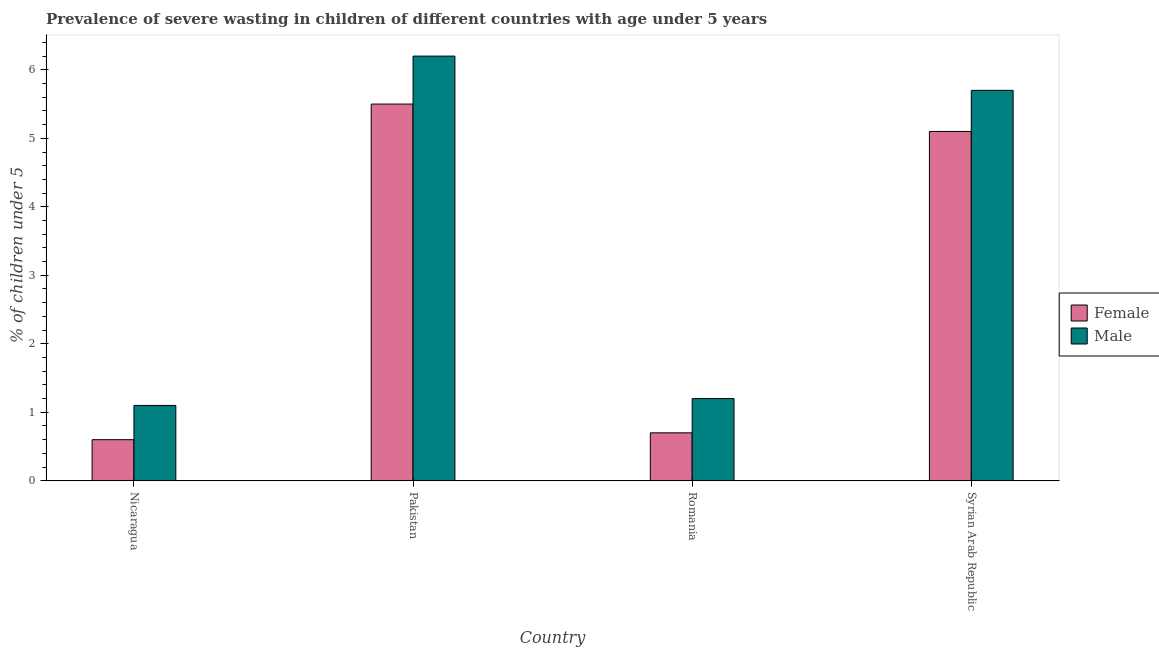Are the number of bars on each tick of the X-axis equal?
Your answer should be very brief. Yes. How many bars are there on the 2nd tick from the right?
Your answer should be compact. 2. What is the label of the 4th group of bars from the left?
Your response must be concise. Syrian Arab Republic. In how many cases, is the number of bars for a given country not equal to the number of legend labels?
Make the answer very short. 0. What is the percentage of undernourished female children in Romania?
Your response must be concise. 0.7. Across all countries, what is the minimum percentage of undernourished female children?
Offer a terse response. 0.6. In which country was the percentage of undernourished male children maximum?
Ensure brevity in your answer.  Pakistan. In which country was the percentage of undernourished male children minimum?
Make the answer very short. Nicaragua. What is the total percentage of undernourished male children in the graph?
Provide a succinct answer. 14.2. What is the difference between the percentage of undernourished male children in Nicaragua and that in Syrian Arab Republic?
Ensure brevity in your answer.  -4.6. What is the difference between the percentage of undernourished male children in Syrian Arab Republic and the percentage of undernourished female children in Nicaragua?
Provide a succinct answer. 5.1. What is the average percentage of undernourished male children per country?
Your answer should be very brief. 3.55. What is the difference between the percentage of undernourished female children and percentage of undernourished male children in Pakistan?
Offer a very short reply. -0.7. What is the ratio of the percentage of undernourished female children in Nicaragua to that in Pakistan?
Provide a succinct answer. 0.11. Is the percentage of undernourished male children in Romania less than that in Syrian Arab Republic?
Give a very brief answer. Yes. Is the difference between the percentage of undernourished male children in Pakistan and Romania greater than the difference between the percentage of undernourished female children in Pakistan and Romania?
Make the answer very short. Yes. What is the difference between the highest and the second highest percentage of undernourished male children?
Make the answer very short. 0.5. What is the difference between the highest and the lowest percentage of undernourished male children?
Keep it short and to the point. 5.1. Is the sum of the percentage of undernourished female children in Nicaragua and Romania greater than the maximum percentage of undernourished male children across all countries?
Make the answer very short. No. What does the 1st bar from the left in Nicaragua represents?
Provide a short and direct response. Female. What does the 1st bar from the right in Romania represents?
Make the answer very short. Male. How many bars are there?
Provide a short and direct response. 8. What is the difference between two consecutive major ticks on the Y-axis?
Your answer should be very brief. 1. Are the values on the major ticks of Y-axis written in scientific E-notation?
Give a very brief answer. No. Does the graph contain any zero values?
Offer a very short reply. No. Does the graph contain grids?
Provide a succinct answer. No. How many legend labels are there?
Provide a succinct answer. 2. What is the title of the graph?
Make the answer very short. Prevalence of severe wasting in children of different countries with age under 5 years. Does "Subsidies" appear as one of the legend labels in the graph?
Your answer should be compact. No. What is the label or title of the Y-axis?
Give a very brief answer.  % of children under 5. What is the  % of children under 5 of Female in Nicaragua?
Keep it short and to the point. 0.6. What is the  % of children under 5 in Male in Nicaragua?
Your response must be concise. 1.1. What is the  % of children under 5 in Female in Pakistan?
Make the answer very short. 5.5. What is the  % of children under 5 in Male in Pakistan?
Give a very brief answer. 6.2. What is the  % of children under 5 in Female in Romania?
Offer a terse response. 0.7. What is the  % of children under 5 in Male in Romania?
Give a very brief answer. 1.2. What is the  % of children under 5 of Female in Syrian Arab Republic?
Offer a terse response. 5.1. What is the  % of children under 5 of Male in Syrian Arab Republic?
Keep it short and to the point. 5.7. Across all countries, what is the maximum  % of children under 5 in Female?
Provide a short and direct response. 5.5. Across all countries, what is the maximum  % of children under 5 in Male?
Give a very brief answer. 6.2. Across all countries, what is the minimum  % of children under 5 in Female?
Offer a terse response. 0.6. Across all countries, what is the minimum  % of children under 5 of Male?
Make the answer very short. 1.1. What is the total  % of children under 5 of Female in the graph?
Offer a very short reply. 11.9. What is the total  % of children under 5 in Male in the graph?
Give a very brief answer. 14.2. What is the difference between the  % of children under 5 in Male in Nicaragua and that in Romania?
Ensure brevity in your answer.  -0.1. What is the difference between the  % of children under 5 in Female in Nicaragua and that in Syrian Arab Republic?
Your answer should be very brief. -4.5. What is the difference between the  % of children under 5 of Female in Pakistan and that in Romania?
Ensure brevity in your answer.  4.8. What is the difference between the  % of children under 5 in Female in Pakistan and that in Syrian Arab Republic?
Your answer should be compact. 0.4. What is the difference between the  % of children under 5 of Male in Pakistan and that in Syrian Arab Republic?
Your response must be concise. 0.5. What is the difference between the  % of children under 5 in Male in Romania and that in Syrian Arab Republic?
Ensure brevity in your answer.  -4.5. What is the difference between the  % of children under 5 of Female in Nicaragua and the  % of children under 5 of Male in Romania?
Keep it short and to the point. -0.6. What is the difference between the  % of children under 5 of Female in Nicaragua and the  % of children under 5 of Male in Syrian Arab Republic?
Offer a very short reply. -5.1. What is the difference between the  % of children under 5 of Female in Pakistan and the  % of children under 5 of Male in Romania?
Keep it short and to the point. 4.3. What is the difference between the  % of children under 5 of Female in Romania and the  % of children under 5 of Male in Syrian Arab Republic?
Make the answer very short. -5. What is the average  % of children under 5 in Female per country?
Keep it short and to the point. 2.98. What is the average  % of children under 5 of Male per country?
Make the answer very short. 3.55. What is the difference between the  % of children under 5 of Female and  % of children under 5 of Male in Romania?
Provide a succinct answer. -0.5. What is the difference between the  % of children under 5 in Female and  % of children under 5 in Male in Syrian Arab Republic?
Provide a succinct answer. -0.6. What is the ratio of the  % of children under 5 of Female in Nicaragua to that in Pakistan?
Keep it short and to the point. 0.11. What is the ratio of the  % of children under 5 in Male in Nicaragua to that in Pakistan?
Your response must be concise. 0.18. What is the ratio of the  % of children under 5 of Female in Nicaragua to that in Syrian Arab Republic?
Provide a succinct answer. 0.12. What is the ratio of the  % of children under 5 of Male in Nicaragua to that in Syrian Arab Republic?
Provide a succinct answer. 0.19. What is the ratio of the  % of children under 5 of Female in Pakistan to that in Romania?
Ensure brevity in your answer.  7.86. What is the ratio of the  % of children under 5 in Male in Pakistan to that in Romania?
Offer a terse response. 5.17. What is the ratio of the  % of children under 5 of Female in Pakistan to that in Syrian Arab Republic?
Provide a succinct answer. 1.08. What is the ratio of the  % of children under 5 in Male in Pakistan to that in Syrian Arab Republic?
Provide a succinct answer. 1.09. What is the ratio of the  % of children under 5 in Female in Romania to that in Syrian Arab Republic?
Give a very brief answer. 0.14. What is the ratio of the  % of children under 5 of Male in Romania to that in Syrian Arab Republic?
Provide a short and direct response. 0.21. What is the difference between the highest and the second highest  % of children under 5 in Male?
Your response must be concise. 0.5. What is the difference between the highest and the lowest  % of children under 5 in Female?
Give a very brief answer. 4.9. 